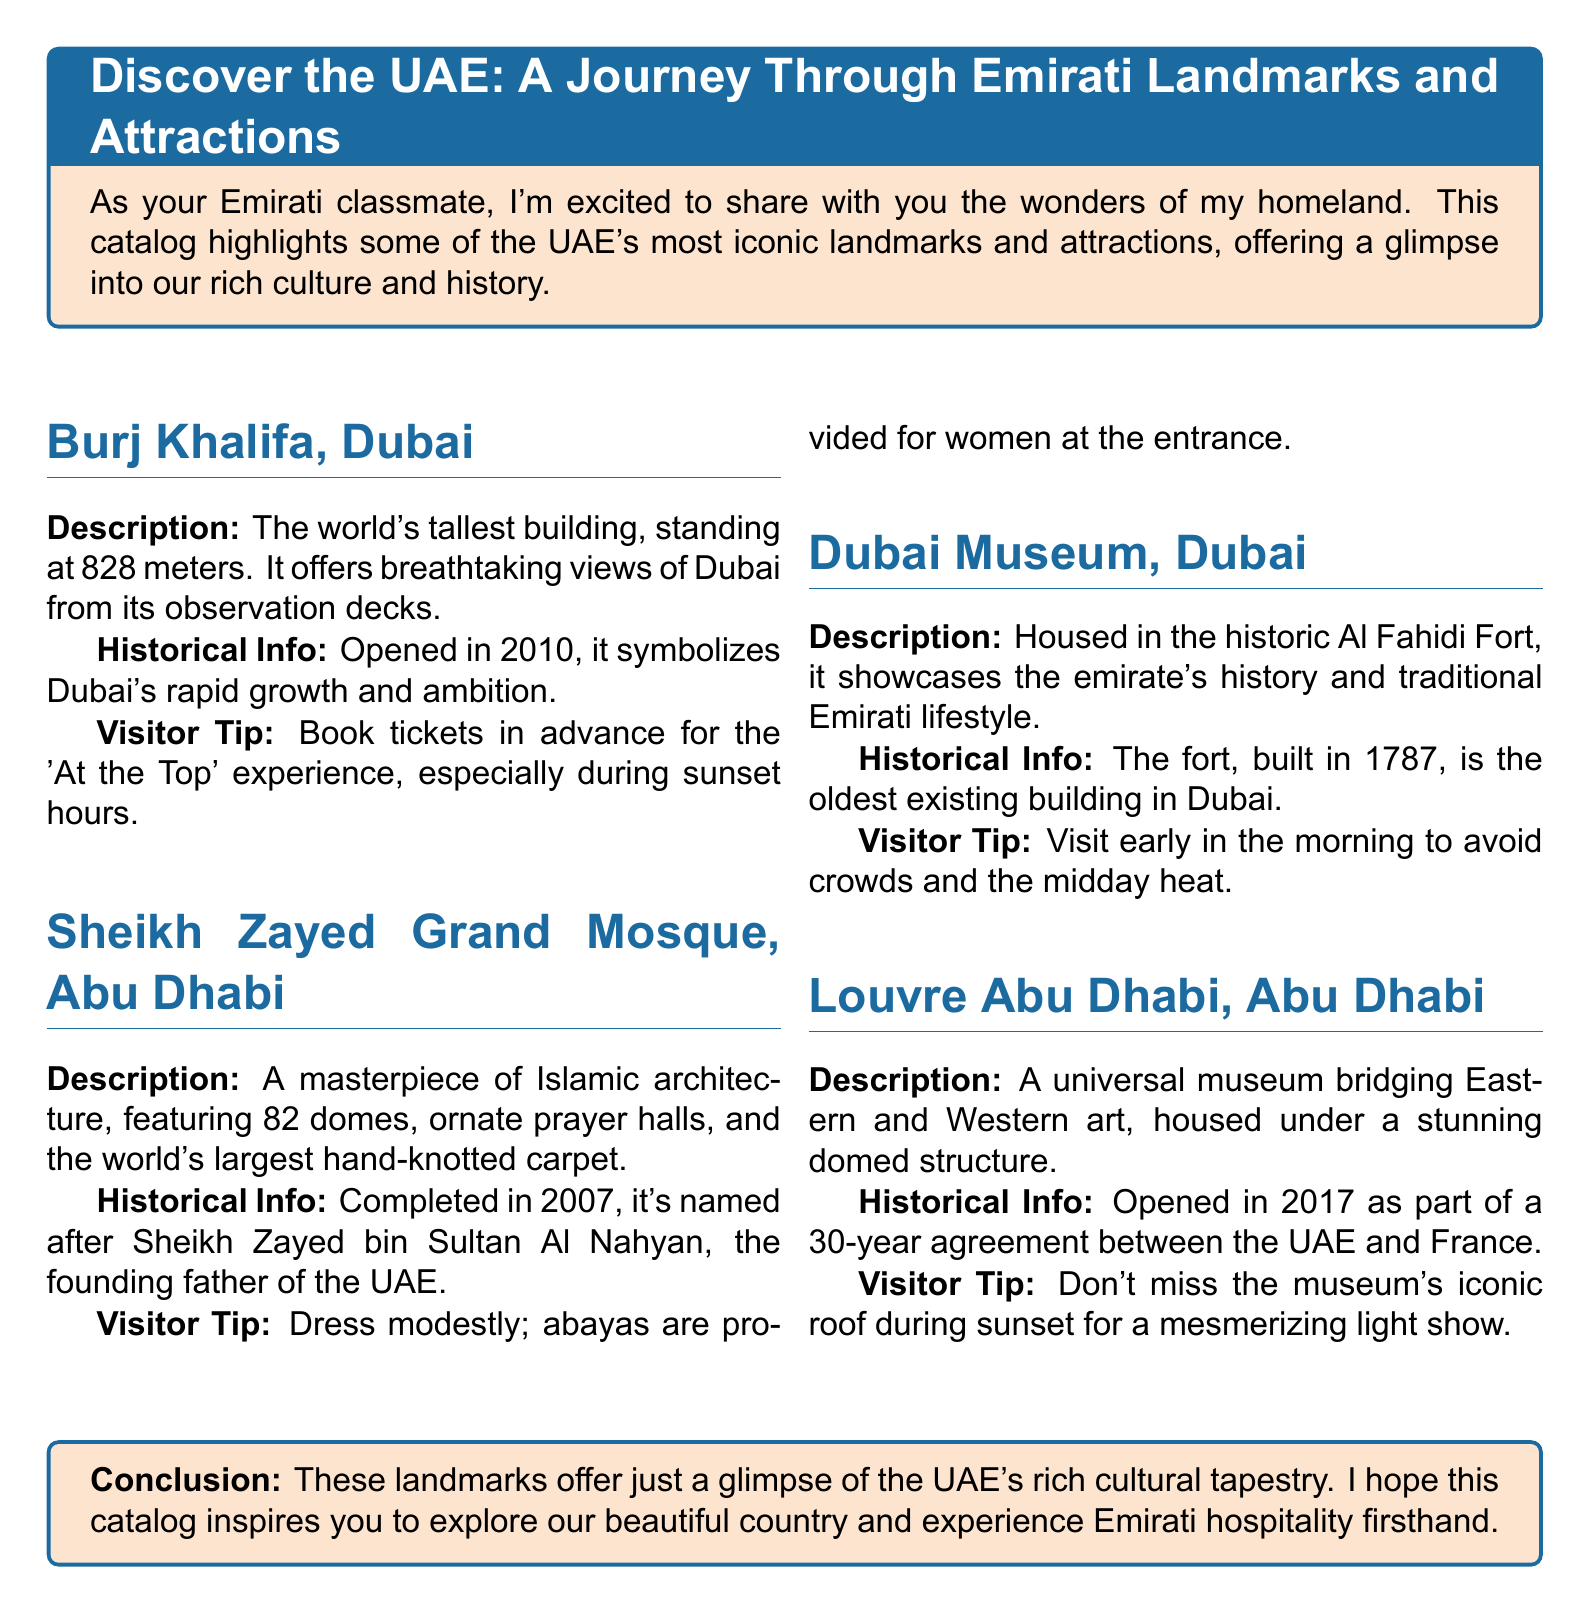What is the height of Burj Khalifa? The height is stated as 828 meters.
Answer: 828 meters When was the Sheikh Zayed Grand Mosque completed? The document mentions that it was completed in 2007.
Answer: 2007 What is unique about the carpet in Sheikh Zayed Grand Mosque? The document indicates that it is the world's largest hand-knotted carpet.
Answer: World's largest hand-knotted carpet In which year did the Louvre Abu Dhabi open? The catalog states that it opened in 2017.
Answer: 2017 What does the Dubai Museum showcase? The document explains that it showcases Dubai's history and traditional Emirati lifestyle.
Answer: Dubai's history and traditional Emirati lifestyle What should visitors wear when visiting the Sheikh Zayed Grand Mosque? The document advises that visitors should dress modestly.
Answer: Dress modestly What is the historical significance of the Dubai Museum? The document notes that the fort, where it is housed, was built in 1787.
Answer: Built in 1787 What type of museum is the Louvre Abu Dhabi described as? It is described in the document as a universal museum bridging Eastern and Western art.
Answer: Universal museum What is a recommended time to visit Dubai Museum? The catalog suggests visiting early in the morning to avoid crowds and heat.
Answer: Early morning 